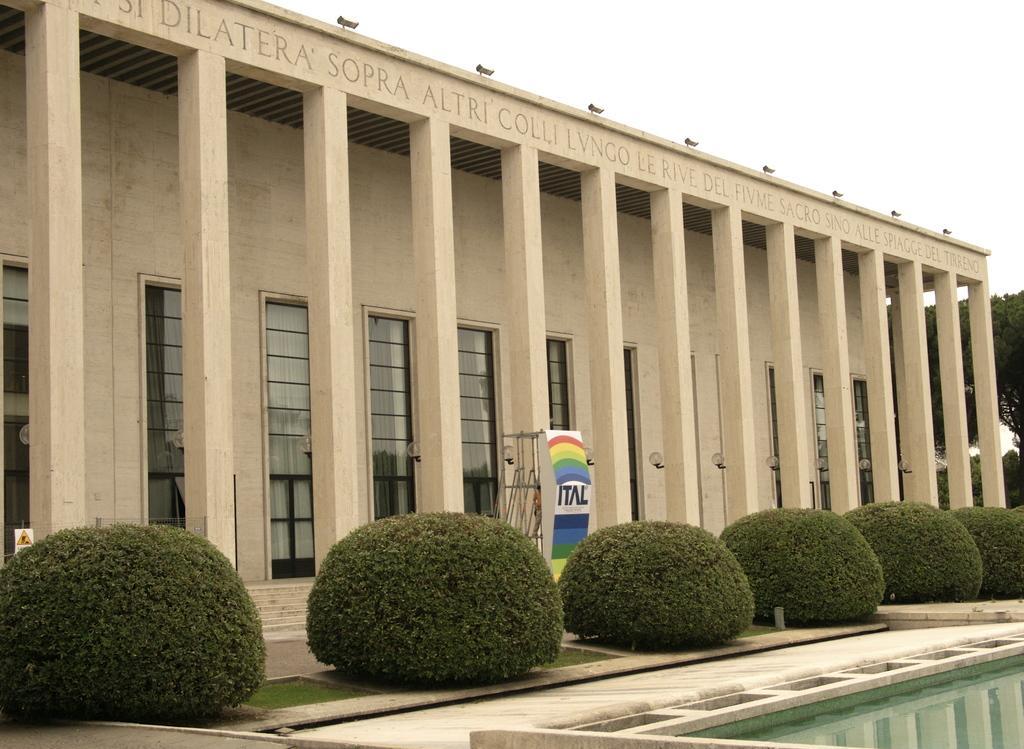How would you summarize this image in a sentence or two? In this image in the front there is water. In the center there are plants. In the background there is a building and on the wall of the building there is some text and there are trees and the sky is cloudy. 